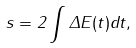<formula> <loc_0><loc_0><loc_500><loc_500>s = 2 \int { \Delta E ( t ) d t } ,</formula> 